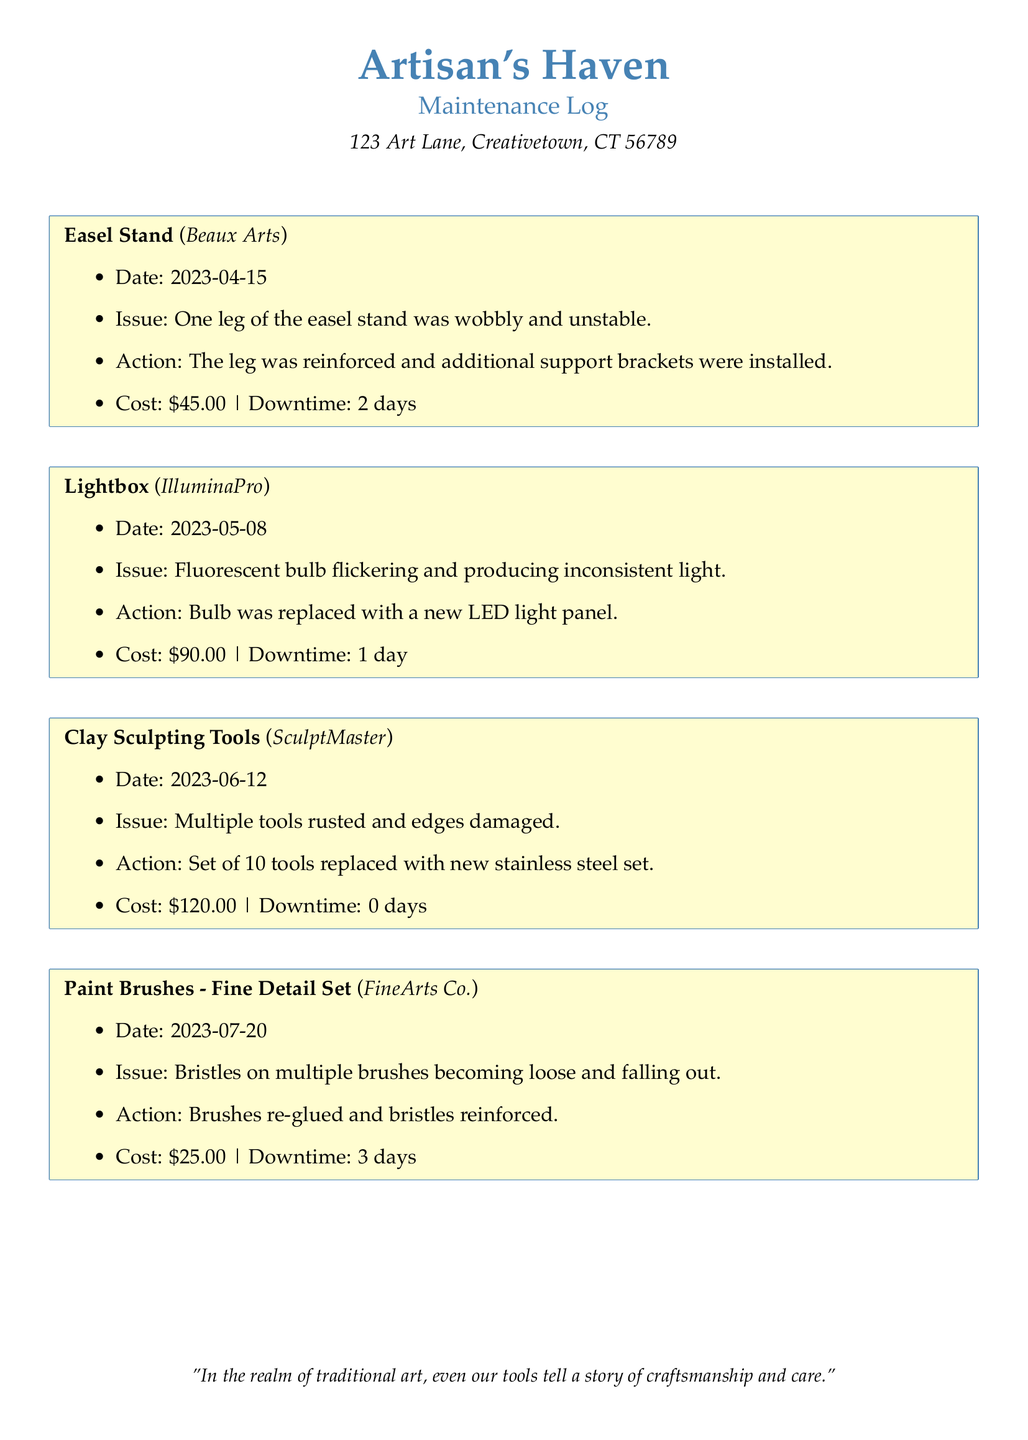What was the issue with the easel stand? The issue with the easel stand was that one leg was wobbly and unstable.
Answer: One leg was wobbly and unstable When was the lightbox repaired? The lightbox was repaired on May 8, 2023.
Answer: 2023-05-08 What was the cost of replacing the clay sculpting tools? The cost of replacing the clay sculpting tools was $120.00.
Answer: $120.00 How many days was the downtime for the painting brushes repair? The downtime for the painting brushes repair was 3 days.
Answer: 3 days What type of light panel was installed in the lightbox? A new LED light panel was installed in the lightbox.
Answer: LED light panel What action was taken to resolve the issue with the easel stand? The leg was reinforced and additional support brackets were installed.
Answer: Reinforced and additional support brackets What materials were used to replace the clay sculpting tools? The clay sculpting tools were replaced with a new stainless steel set.
Answer: stainless steel set What is the date of the maintenance log entry for the paint brushes? The date of the maintenance log entry for the paint brushes is July 20, 2023.
Answer: 2023-07-20 How many tools were in the set that was replaced? The set that was replaced contained 10 tools.
Answer: 10 tools 